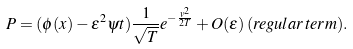Convert formula to latex. <formula><loc_0><loc_0><loc_500><loc_500>P = ( \phi ( x ) - \varepsilon ^ { 2 } \psi t ) \frac { 1 } { \sqrt { T } } e ^ { - \frac { v ^ { 2 } } { 2 T } } + O ( \varepsilon ) \, ( r e g u l a r \, t e r m ) .</formula> 